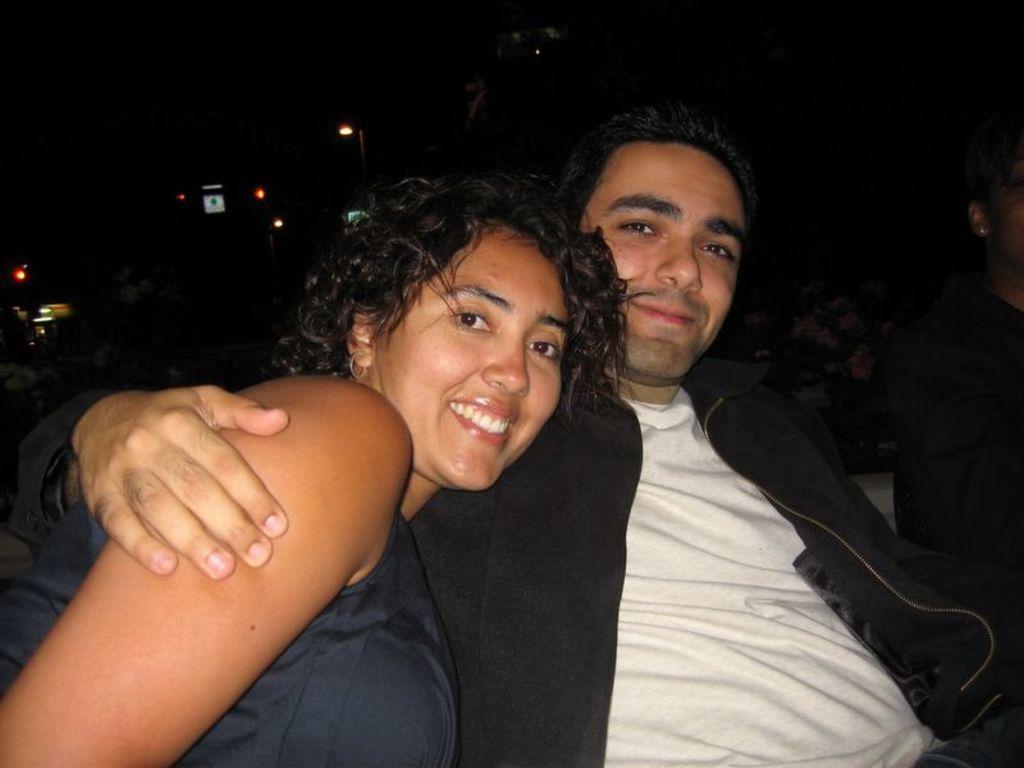Describe this image in one or two sentences. In this image, on the middle and on the left side, we can see two persons man and woman are sitting. On the right side, we can see another person. In the background, we can see some street lights, hoardings. 